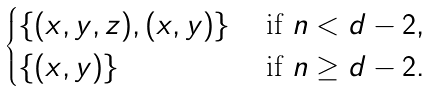<formula> <loc_0><loc_0><loc_500><loc_500>\begin{cases} \{ ( x , y , z ) , ( x , y ) \} & \ \text {if} \ n < d - 2 , \\ \{ ( x , y ) \} & \ \text {if} \ n \geq d - 2 . \end{cases}</formula> 